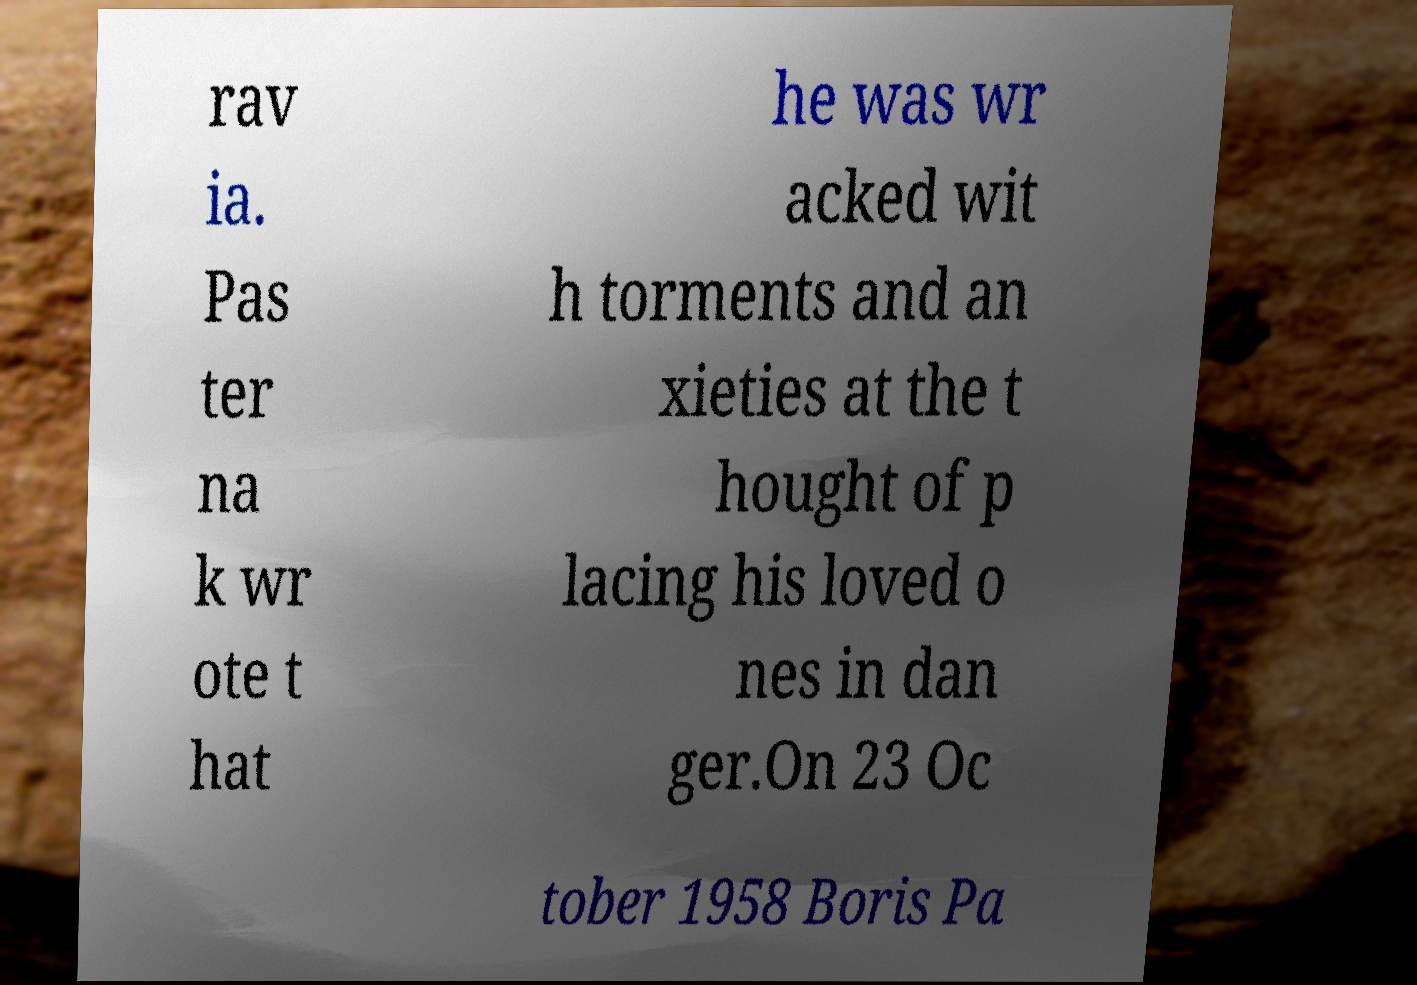Please identify and transcribe the text found in this image. rav ia. Pas ter na k wr ote t hat he was wr acked wit h torments and an xieties at the t hought of p lacing his loved o nes in dan ger.On 23 Oc tober 1958 Boris Pa 